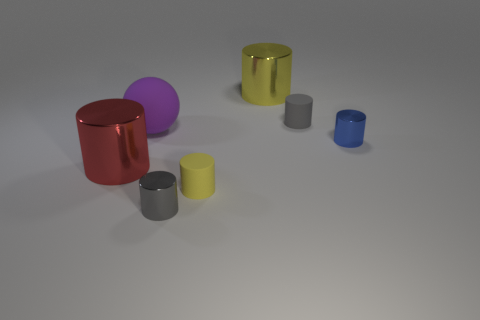Do the large yellow shiny thing and the yellow thing in front of the red cylinder have the same shape?
Your answer should be very brief. Yes. What number of other objects are the same size as the gray metallic cylinder?
Your response must be concise. 3. What number of yellow objects are either tiny metal cylinders or large matte balls?
Your response must be concise. 0. How many metal objects are in front of the small gray matte cylinder and to the right of the large red cylinder?
Offer a terse response. 2. There is a small gray object behind the tiny gray cylinder that is in front of the purple sphere to the left of the tiny gray rubber object; what is its material?
Your answer should be compact. Rubber. What number of purple spheres have the same material as the tiny blue object?
Offer a terse response. 0. The red thing that is the same size as the matte ball is what shape?
Your response must be concise. Cylinder. Are there any large yellow metal cylinders right of the tiny blue metallic thing?
Ensure brevity in your answer.  No. Are there any other large red metallic things of the same shape as the big red thing?
Your answer should be compact. No. Does the rubber thing that is to the left of the small yellow object have the same shape as the tiny metallic object that is right of the large yellow cylinder?
Keep it short and to the point. No. 